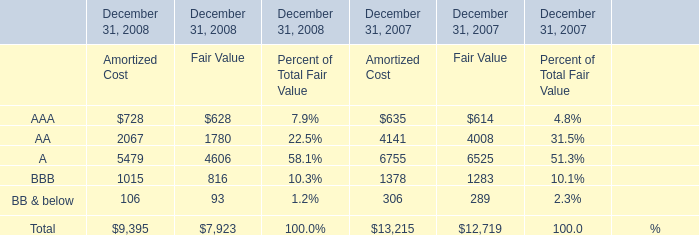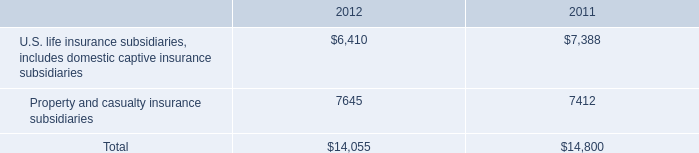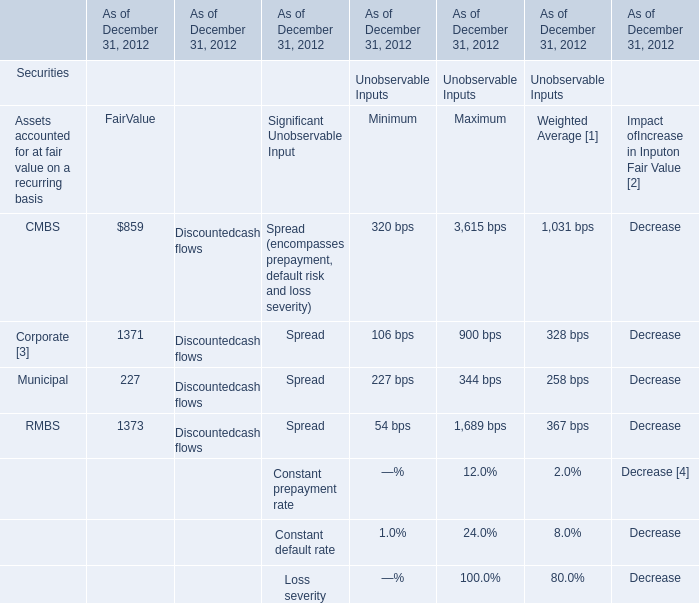What is the average amount of AA of December 31, 2008 Fair Value, and Property and casualty insurance subsidiaries of 2012 ? 
Computations: ((1780.0 + 7645.0) / 2)
Answer: 4712.5. 